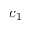<formula> <loc_0><loc_0><loc_500><loc_500>c _ { 1 }</formula> 